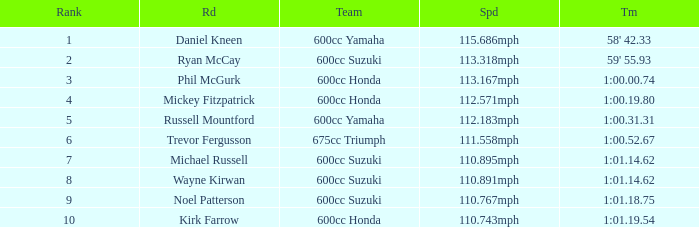What time has phil mcgurk as the rider? 1:00.00.74. 